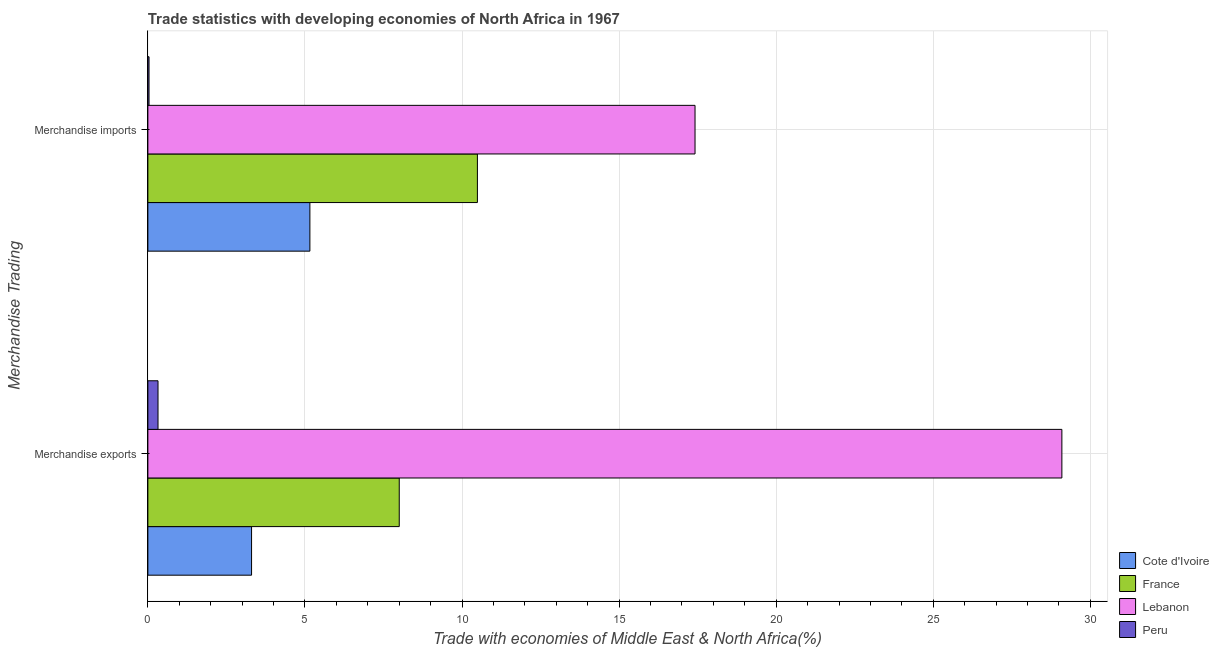How many different coloured bars are there?
Ensure brevity in your answer.  4. How many groups of bars are there?
Provide a succinct answer. 2. Are the number of bars on each tick of the Y-axis equal?
Offer a very short reply. Yes. What is the merchandise imports in Cote d'Ivoire?
Ensure brevity in your answer.  5.16. Across all countries, what is the maximum merchandise imports?
Make the answer very short. 17.42. Across all countries, what is the minimum merchandise exports?
Ensure brevity in your answer.  0.32. In which country was the merchandise imports maximum?
Your response must be concise. Lebanon. What is the total merchandise imports in the graph?
Provide a short and direct response. 33.1. What is the difference between the merchandise exports in France and that in Peru?
Provide a succinct answer. 7.68. What is the difference between the merchandise imports in Lebanon and the merchandise exports in Cote d'Ivoire?
Provide a short and direct response. 14.12. What is the average merchandise exports per country?
Ensure brevity in your answer.  10.18. What is the difference between the merchandise imports and merchandise exports in Cote d'Ivoire?
Ensure brevity in your answer.  1.86. What is the ratio of the merchandise imports in Cote d'Ivoire to that in Lebanon?
Give a very brief answer. 0.3. What does the 3rd bar from the bottom in Merchandise exports represents?
Give a very brief answer. Lebanon. How many bars are there?
Offer a terse response. 8. Are all the bars in the graph horizontal?
Your response must be concise. Yes. How many countries are there in the graph?
Offer a terse response. 4. What is the difference between two consecutive major ticks on the X-axis?
Provide a succinct answer. 5. Are the values on the major ticks of X-axis written in scientific E-notation?
Ensure brevity in your answer.  No. Does the graph contain any zero values?
Give a very brief answer. No. How many legend labels are there?
Offer a very short reply. 4. What is the title of the graph?
Your answer should be compact. Trade statistics with developing economies of North Africa in 1967. What is the label or title of the X-axis?
Your answer should be very brief. Trade with economies of Middle East & North Africa(%). What is the label or title of the Y-axis?
Your answer should be compact. Merchandise Trading. What is the Trade with economies of Middle East & North Africa(%) of Cote d'Ivoire in Merchandise exports?
Keep it short and to the point. 3.3. What is the Trade with economies of Middle East & North Africa(%) in France in Merchandise exports?
Provide a succinct answer. 8. What is the Trade with economies of Middle East & North Africa(%) in Lebanon in Merchandise exports?
Your answer should be compact. 29.09. What is the Trade with economies of Middle East & North Africa(%) in Peru in Merchandise exports?
Ensure brevity in your answer.  0.32. What is the Trade with economies of Middle East & North Africa(%) of Cote d'Ivoire in Merchandise imports?
Your answer should be very brief. 5.16. What is the Trade with economies of Middle East & North Africa(%) in France in Merchandise imports?
Provide a succinct answer. 10.49. What is the Trade with economies of Middle East & North Africa(%) in Lebanon in Merchandise imports?
Your answer should be compact. 17.42. What is the Trade with economies of Middle East & North Africa(%) in Peru in Merchandise imports?
Ensure brevity in your answer.  0.04. Across all Merchandise Trading, what is the maximum Trade with economies of Middle East & North Africa(%) in Cote d'Ivoire?
Your answer should be compact. 5.16. Across all Merchandise Trading, what is the maximum Trade with economies of Middle East & North Africa(%) of France?
Offer a terse response. 10.49. Across all Merchandise Trading, what is the maximum Trade with economies of Middle East & North Africa(%) in Lebanon?
Keep it short and to the point. 29.09. Across all Merchandise Trading, what is the maximum Trade with economies of Middle East & North Africa(%) in Peru?
Your answer should be compact. 0.32. Across all Merchandise Trading, what is the minimum Trade with economies of Middle East & North Africa(%) of Cote d'Ivoire?
Your answer should be very brief. 3.3. Across all Merchandise Trading, what is the minimum Trade with economies of Middle East & North Africa(%) of France?
Provide a succinct answer. 8. Across all Merchandise Trading, what is the minimum Trade with economies of Middle East & North Africa(%) in Lebanon?
Make the answer very short. 17.42. Across all Merchandise Trading, what is the minimum Trade with economies of Middle East & North Africa(%) in Peru?
Your answer should be compact. 0.04. What is the total Trade with economies of Middle East & North Africa(%) in Cote d'Ivoire in the graph?
Ensure brevity in your answer.  8.46. What is the total Trade with economies of Middle East & North Africa(%) of France in the graph?
Make the answer very short. 18.49. What is the total Trade with economies of Middle East & North Africa(%) of Lebanon in the graph?
Offer a terse response. 46.51. What is the total Trade with economies of Middle East & North Africa(%) in Peru in the graph?
Give a very brief answer. 0.36. What is the difference between the Trade with economies of Middle East & North Africa(%) in Cote d'Ivoire in Merchandise exports and that in Merchandise imports?
Your response must be concise. -1.86. What is the difference between the Trade with economies of Middle East & North Africa(%) of France in Merchandise exports and that in Merchandise imports?
Ensure brevity in your answer.  -2.49. What is the difference between the Trade with economies of Middle East & North Africa(%) of Lebanon in Merchandise exports and that in Merchandise imports?
Provide a succinct answer. 11.68. What is the difference between the Trade with economies of Middle East & North Africa(%) of Peru in Merchandise exports and that in Merchandise imports?
Your answer should be compact. 0.29. What is the difference between the Trade with economies of Middle East & North Africa(%) of Cote d'Ivoire in Merchandise exports and the Trade with economies of Middle East & North Africa(%) of France in Merchandise imports?
Your answer should be compact. -7.19. What is the difference between the Trade with economies of Middle East & North Africa(%) of Cote d'Ivoire in Merchandise exports and the Trade with economies of Middle East & North Africa(%) of Lebanon in Merchandise imports?
Ensure brevity in your answer.  -14.12. What is the difference between the Trade with economies of Middle East & North Africa(%) in Cote d'Ivoire in Merchandise exports and the Trade with economies of Middle East & North Africa(%) in Peru in Merchandise imports?
Offer a very short reply. 3.26. What is the difference between the Trade with economies of Middle East & North Africa(%) in France in Merchandise exports and the Trade with economies of Middle East & North Africa(%) in Lebanon in Merchandise imports?
Your answer should be very brief. -9.42. What is the difference between the Trade with economies of Middle East & North Africa(%) in France in Merchandise exports and the Trade with economies of Middle East & North Africa(%) in Peru in Merchandise imports?
Keep it short and to the point. 7.96. What is the difference between the Trade with economies of Middle East & North Africa(%) in Lebanon in Merchandise exports and the Trade with economies of Middle East & North Africa(%) in Peru in Merchandise imports?
Keep it short and to the point. 29.06. What is the average Trade with economies of Middle East & North Africa(%) of Cote d'Ivoire per Merchandise Trading?
Your answer should be very brief. 4.23. What is the average Trade with economies of Middle East & North Africa(%) of France per Merchandise Trading?
Your answer should be compact. 9.25. What is the average Trade with economies of Middle East & North Africa(%) in Lebanon per Merchandise Trading?
Ensure brevity in your answer.  23.26. What is the average Trade with economies of Middle East & North Africa(%) in Peru per Merchandise Trading?
Offer a terse response. 0.18. What is the difference between the Trade with economies of Middle East & North Africa(%) in Cote d'Ivoire and Trade with economies of Middle East & North Africa(%) in France in Merchandise exports?
Ensure brevity in your answer.  -4.7. What is the difference between the Trade with economies of Middle East & North Africa(%) in Cote d'Ivoire and Trade with economies of Middle East & North Africa(%) in Lebanon in Merchandise exports?
Give a very brief answer. -25.79. What is the difference between the Trade with economies of Middle East & North Africa(%) of Cote d'Ivoire and Trade with economies of Middle East & North Africa(%) of Peru in Merchandise exports?
Offer a very short reply. 2.98. What is the difference between the Trade with economies of Middle East & North Africa(%) in France and Trade with economies of Middle East & North Africa(%) in Lebanon in Merchandise exports?
Your answer should be very brief. -21.09. What is the difference between the Trade with economies of Middle East & North Africa(%) in France and Trade with economies of Middle East & North Africa(%) in Peru in Merchandise exports?
Provide a short and direct response. 7.68. What is the difference between the Trade with economies of Middle East & North Africa(%) in Lebanon and Trade with economies of Middle East & North Africa(%) in Peru in Merchandise exports?
Your answer should be very brief. 28.77. What is the difference between the Trade with economies of Middle East & North Africa(%) in Cote d'Ivoire and Trade with economies of Middle East & North Africa(%) in France in Merchandise imports?
Provide a short and direct response. -5.33. What is the difference between the Trade with economies of Middle East & North Africa(%) in Cote d'Ivoire and Trade with economies of Middle East & North Africa(%) in Lebanon in Merchandise imports?
Offer a very short reply. -12.26. What is the difference between the Trade with economies of Middle East & North Africa(%) in Cote d'Ivoire and Trade with economies of Middle East & North Africa(%) in Peru in Merchandise imports?
Offer a very short reply. 5.12. What is the difference between the Trade with economies of Middle East & North Africa(%) in France and Trade with economies of Middle East & North Africa(%) in Lebanon in Merchandise imports?
Your response must be concise. -6.93. What is the difference between the Trade with economies of Middle East & North Africa(%) in France and Trade with economies of Middle East & North Africa(%) in Peru in Merchandise imports?
Provide a short and direct response. 10.45. What is the difference between the Trade with economies of Middle East & North Africa(%) of Lebanon and Trade with economies of Middle East & North Africa(%) of Peru in Merchandise imports?
Provide a succinct answer. 17.38. What is the ratio of the Trade with economies of Middle East & North Africa(%) of Cote d'Ivoire in Merchandise exports to that in Merchandise imports?
Provide a short and direct response. 0.64. What is the ratio of the Trade with economies of Middle East & North Africa(%) of France in Merchandise exports to that in Merchandise imports?
Offer a very short reply. 0.76. What is the ratio of the Trade with economies of Middle East & North Africa(%) in Lebanon in Merchandise exports to that in Merchandise imports?
Offer a very short reply. 1.67. What is the ratio of the Trade with economies of Middle East & North Africa(%) of Peru in Merchandise exports to that in Merchandise imports?
Keep it short and to the point. 8.76. What is the difference between the highest and the second highest Trade with economies of Middle East & North Africa(%) in Cote d'Ivoire?
Offer a very short reply. 1.86. What is the difference between the highest and the second highest Trade with economies of Middle East & North Africa(%) of France?
Make the answer very short. 2.49. What is the difference between the highest and the second highest Trade with economies of Middle East & North Africa(%) in Lebanon?
Provide a short and direct response. 11.68. What is the difference between the highest and the second highest Trade with economies of Middle East & North Africa(%) of Peru?
Offer a very short reply. 0.29. What is the difference between the highest and the lowest Trade with economies of Middle East & North Africa(%) of Cote d'Ivoire?
Your response must be concise. 1.86. What is the difference between the highest and the lowest Trade with economies of Middle East & North Africa(%) in France?
Offer a terse response. 2.49. What is the difference between the highest and the lowest Trade with economies of Middle East & North Africa(%) in Lebanon?
Keep it short and to the point. 11.68. What is the difference between the highest and the lowest Trade with economies of Middle East & North Africa(%) in Peru?
Your response must be concise. 0.29. 